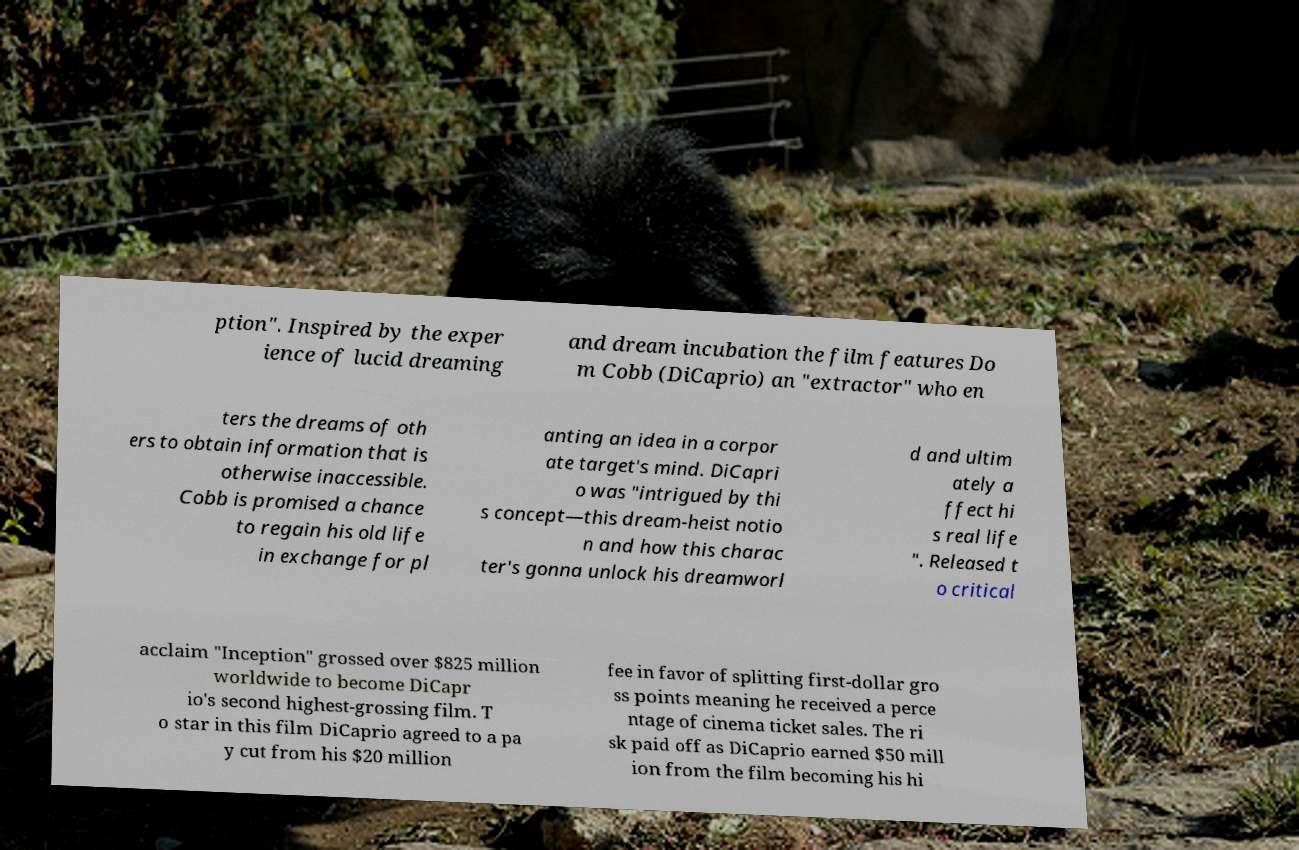There's text embedded in this image that I need extracted. Can you transcribe it verbatim? ption". Inspired by the exper ience of lucid dreaming and dream incubation the film features Do m Cobb (DiCaprio) an "extractor" who en ters the dreams of oth ers to obtain information that is otherwise inaccessible. Cobb is promised a chance to regain his old life in exchange for pl anting an idea in a corpor ate target's mind. DiCapri o was "intrigued by thi s concept—this dream-heist notio n and how this charac ter's gonna unlock his dreamworl d and ultim ately a ffect hi s real life ". Released t o critical acclaim "Inception" grossed over $825 million worldwide to become DiCapr io's second highest-grossing film. T o star in this film DiCaprio agreed to a pa y cut from his $20 million fee in favor of splitting first-dollar gro ss points meaning he received a perce ntage of cinema ticket sales. The ri sk paid off as DiCaprio earned $50 mill ion from the film becoming his hi 